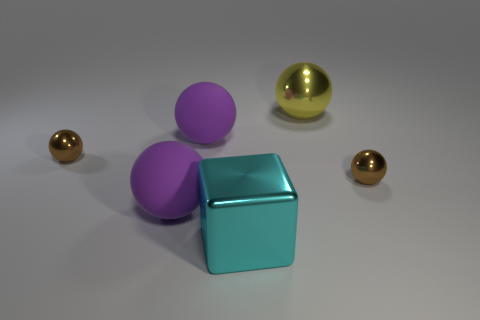There is a brown thing that is to the left of the yellow shiny ball; is its shape the same as the yellow metallic thing?
Ensure brevity in your answer.  Yes. What number of things are large purple objects or small spheres that are left of the large cyan thing?
Your answer should be compact. 3. Are there fewer tiny spheres than large objects?
Your response must be concise. Yes. Is the number of small metal balls greater than the number of cyan metal objects?
Ensure brevity in your answer.  Yes. How many other things are there of the same material as the big yellow thing?
Ensure brevity in your answer.  3. There is a brown metallic thing right of the big metal thing in front of the big yellow sphere; what number of large balls are behind it?
Give a very brief answer. 2. How many shiny objects are either tiny cyan cubes or large purple things?
Keep it short and to the point. 0. How big is the object right of the large yellow object that is on the right side of the cyan shiny object?
Offer a very short reply. Small. There is a tiny metal object to the right of the cyan metal thing; is it the same color as the block that is on the left side of the big yellow ball?
Ensure brevity in your answer.  No. What color is the shiny object that is behind the cyan thing and on the left side of the yellow thing?
Provide a succinct answer. Brown. 